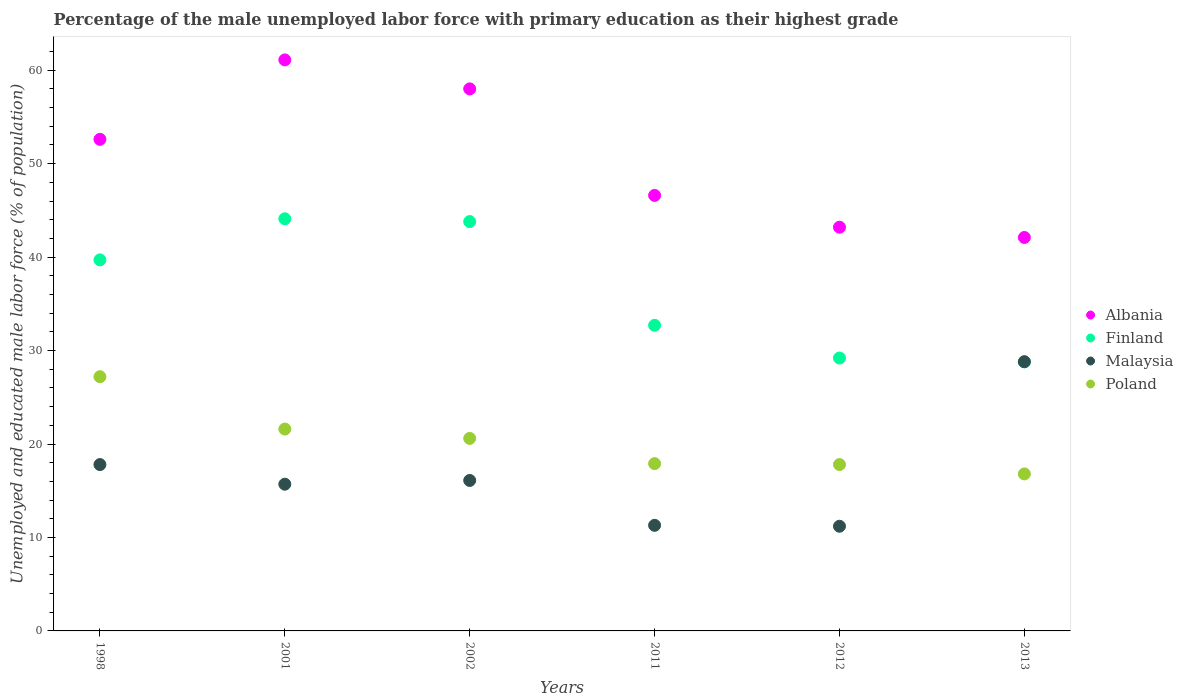How many different coloured dotlines are there?
Keep it short and to the point. 4. What is the percentage of the unemployed male labor force with primary education in Malaysia in 2011?
Provide a short and direct response. 11.3. Across all years, what is the maximum percentage of the unemployed male labor force with primary education in Malaysia?
Ensure brevity in your answer.  28.8. Across all years, what is the minimum percentage of the unemployed male labor force with primary education in Malaysia?
Your answer should be compact. 11.2. In which year was the percentage of the unemployed male labor force with primary education in Poland maximum?
Ensure brevity in your answer.  1998. What is the total percentage of the unemployed male labor force with primary education in Poland in the graph?
Offer a very short reply. 121.9. What is the difference between the percentage of the unemployed male labor force with primary education in Malaysia in 2001 and that in 2013?
Your answer should be very brief. -13.1. What is the difference between the percentage of the unemployed male labor force with primary education in Albania in 2001 and the percentage of the unemployed male labor force with primary education in Finland in 2012?
Your response must be concise. 31.9. What is the average percentage of the unemployed male labor force with primary education in Finland per year?
Ensure brevity in your answer.  36.38. In the year 1998, what is the difference between the percentage of the unemployed male labor force with primary education in Malaysia and percentage of the unemployed male labor force with primary education in Finland?
Offer a very short reply. -21.9. In how many years, is the percentage of the unemployed male labor force with primary education in Albania greater than 28 %?
Your response must be concise. 6. What is the ratio of the percentage of the unemployed male labor force with primary education in Poland in 2012 to that in 2013?
Offer a very short reply. 1.06. Is the percentage of the unemployed male labor force with primary education in Malaysia in 1998 less than that in 2011?
Provide a succinct answer. No. What is the difference between the highest and the second highest percentage of the unemployed male labor force with primary education in Malaysia?
Offer a terse response. 11. What is the difference between the highest and the lowest percentage of the unemployed male labor force with primary education in Malaysia?
Offer a terse response. 17.6. In how many years, is the percentage of the unemployed male labor force with primary education in Albania greater than the average percentage of the unemployed male labor force with primary education in Albania taken over all years?
Make the answer very short. 3. Is it the case that in every year, the sum of the percentage of the unemployed male labor force with primary education in Malaysia and percentage of the unemployed male labor force with primary education in Finland  is greater than the percentage of the unemployed male labor force with primary education in Poland?
Provide a short and direct response. Yes. Does the percentage of the unemployed male labor force with primary education in Albania monotonically increase over the years?
Keep it short and to the point. No. Is the percentage of the unemployed male labor force with primary education in Poland strictly greater than the percentage of the unemployed male labor force with primary education in Albania over the years?
Provide a short and direct response. No. How many dotlines are there?
Keep it short and to the point. 4. What is the difference between two consecutive major ticks on the Y-axis?
Your answer should be very brief. 10. Are the values on the major ticks of Y-axis written in scientific E-notation?
Give a very brief answer. No. Does the graph contain grids?
Keep it short and to the point. No. Where does the legend appear in the graph?
Give a very brief answer. Center right. How many legend labels are there?
Your answer should be compact. 4. How are the legend labels stacked?
Your answer should be compact. Vertical. What is the title of the graph?
Your response must be concise. Percentage of the male unemployed labor force with primary education as their highest grade. Does "Ukraine" appear as one of the legend labels in the graph?
Offer a very short reply. No. What is the label or title of the X-axis?
Your answer should be compact. Years. What is the label or title of the Y-axis?
Keep it short and to the point. Unemployed and educated male labor force (% of population). What is the Unemployed and educated male labor force (% of population) in Albania in 1998?
Provide a succinct answer. 52.6. What is the Unemployed and educated male labor force (% of population) of Finland in 1998?
Provide a short and direct response. 39.7. What is the Unemployed and educated male labor force (% of population) of Malaysia in 1998?
Provide a succinct answer. 17.8. What is the Unemployed and educated male labor force (% of population) of Poland in 1998?
Make the answer very short. 27.2. What is the Unemployed and educated male labor force (% of population) in Albania in 2001?
Your answer should be very brief. 61.1. What is the Unemployed and educated male labor force (% of population) of Finland in 2001?
Make the answer very short. 44.1. What is the Unemployed and educated male labor force (% of population) of Malaysia in 2001?
Keep it short and to the point. 15.7. What is the Unemployed and educated male labor force (% of population) in Poland in 2001?
Provide a short and direct response. 21.6. What is the Unemployed and educated male labor force (% of population) of Albania in 2002?
Your response must be concise. 58. What is the Unemployed and educated male labor force (% of population) in Finland in 2002?
Ensure brevity in your answer.  43.8. What is the Unemployed and educated male labor force (% of population) in Malaysia in 2002?
Offer a terse response. 16.1. What is the Unemployed and educated male labor force (% of population) of Poland in 2002?
Give a very brief answer. 20.6. What is the Unemployed and educated male labor force (% of population) of Albania in 2011?
Ensure brevity in your answer.  46.6. What is the Unemployed and educated male labor force (% of population) in Finland in 2011?
Make the answer very short. 32.7. What is the Unemployed and educated male labor force (% of population) in Malaysia in 2011?
Offer a very short reply. 11.3. What is the Unemployed and educated male labor force (% of population) in Poland in 2011?
Provide a succinct answer. 17.9. What is the Unemployed and educated male labor force (% of population) in Albania in 2012?
Your answer should be very brief. 43.2. What is the Unemployed and educated male labor force (% of population) in Finland in 2012?
Keep it short and to the point. 29.2. What is the Unemployed and educated male labor force (% of population) of Malaysia in 2012?
Make the answer very short. 11.2. What is the Unemployed and educated male labor force (% of population) in Poland in 2012?
Provide a short and direct response. 17.8. What is the Unemployed and educated male labor force (% of population) in Albania in 2013?
Your response must be concise. 42.1. What is the Unemployed and educated male labor force (% of population) in Finland in 2013?
Your answer should be compact. 28.8. What is the Unemployed and educated male labor force (% of population) of Malaysia in 2013?
Keep it short and to the point. 28.8. What is the Unemployed and educated male labor force (% of population) of Poland in 2013?
Offer a terse response. 16.8. Across all years, what is the maximum Unemployed and educated male labor force (% of population) in Albania?
Your answer should be compact. 61.1. Across all years, what is the maximum Unemployed and educated male labor force (% of population) of Finland?
Provide a short and direct response. 44.1. Across all years, what is the maximum Unemployed and educated male labor force (% of population) of Malaysia?
Make the answer very short. 28.8. Across all years, what is the maximum Unemployed and educated male labor force (% of population) of Poland?
Offer a very short reply. 27.2. Across all years, what is the minimum Unemployed and educated male labor force (% of population) in Albania?
Your answer should be compact. 42.1. Across all years, what is the minimum Unemployed and educated male labor force (% of population) in Finland?
Offer a very short reply. 28.8. Across all years, what is the minimum Unemployed and educated male labor force (% of population) in Malaysia?
Provide a succinct answer. 11.2. Across all years, what is the minimum Unemployed and educated male labor force (% of population) in Poland?
Offer a terse response. 16.8. What is the total Unemployed and educated male labor force (% of population) in Albania in the graph?
Your answer should be very brief. 303.6. What is the total Unemployed and educated male labor force (% of population) of Finland in the graph?
Offer a very short reply. 218.3. What is the total Unemployed and educated male labor force (% of population) in Malaysia in the graph?
Give a very brief answer. 100.9. What is the total Unemployed and educated male labor force (% of population) in Poland in the graph?
Offer a terse response. 121.9. What is the difference between the Unemployed and educated male labor force (% of population) in Albania in 1998 and that in 2001?
Ensure brevity in your answer.  -8.5. What is the difference between the Unemployed and educated male labor force (% of population) in Poland in 1998 and that in 2001?
Provide a short and direct response. 5.6. What is the difference between the Unemployed and educated male labor force (% of population) in Malaysia in 1998 and that in 2011?
Your answer should be very brief. 6.5. What is the difference between the Unemployed and educated male labor force (% of population) in Poland in 1998 and that in 2011?
Make the answer very short. 9.3. What is the difference between the Unemployed and educated male labor force (% of population) of Albania in 1998 and that in 2012?
Keep it short and to the point. 9.4. What is the difference between the Unemployed and educated male labor force (% of population) in Finland in 1998 and that in 2012?
Your response must be concise. 10.5. What is the difference between the Unemployed and educated male labor force (% of population) of Malaysia in 1998 and that in 2012?
Your answer should be compact. 6.6. What is the difference between the Unemployed and educated male labor force (% of population) of Albania in 1998 and that in 2013?
Provide a short and direct response. 10.5. What is the difference between the Unemployed and educated male labor force (% of population) in Poland in 1998 and that in 2013?
Ensure brevity in your answer.  10.4. What is the difference between the Unemployed and educated male labor force (% of population) in Finland in 2001 and that in 2002?
Offer a very short reply. 0.3. What is the difference between the Unemployed and educated male labor force (% of population) of Malaysia in 2001 and that in 2002?
Your answer should be very brief. -0.4. What is the difference between the Unemployed and educated male labor force (% of population) in Poland in 2001 and that in 2002?
Keep it short and to the point. 1. What is the difference between the Unemployed and educated male labor force (% of population) in Albania in 2001 and that in 2011?
Provide a short and direct response. 14.5. What is the difference between the Unemployed and educated male labor force (% of population) in Malaysia in 2001 and that in 2011?
Your answer should be compact. 4.4. What is the difference between the Unemployed and educated male labor force (% of population) in Albania in 2001 and that in 2012?
Provide a short and direct response. 17.9. What is the difference between the Unemployed and educated male labor force (% of population) in Malaysia in 2001 and that in 2012?
Keep it short and to the point. 4.5. What is the difference between the Unemployed and educated male labor force (% of population) of Poland in 2001 and that in 2013?
Make the answer very short. 4.8. What is the difference between the Unemployed and educated male labor force (% of population) of Finland in 2002 and that in 2011?
Give a very brief answer. 11.1. What is the difference between the Unemployed and educated male labor force (% of population) in Malaysia in 2002 and that in 2011?
Your answer should be very brief. 4.8. What is the difference between the Unemployed and educated male labor force (% of population) of Poland in 2002 and that in 2011?
Offer a terse response. 2.7. What is the difference between the Unemployed and educated male labor force (% of population) in Albania in 2002 and that in 2012?
Provide a short and direct response. 14.8. What is the difference between the Unemployed and educated male labor force (% of population) of Malaysia in 2002 and that in 2013?
Keep it short and to the point. -12.7. What is the difference between the Unemployed and educated male labor force (% of population) of Albania in 2011 and that in 2012?
Offer a terse response. 3.4. What is the difference between the Unemployed and educated male labor force (% of population) in Malaysia in 2011 and that in 2012?
Offer a very short reply. 0.1. What is the difference between the Unemployed and educated male labor force (% of population) of Poland in 2011 and that in 2012?
Keep it short and to the point. 0.1. What is the difference between the Unemployed and educated male labor force (% of population) in Albania in 2011 and that in 2013?
Give a very brief answer. 4.5. What is the difference between the Unemployed and educated male labor force (% of population) of Malaysia in 2011 and that in 2013?
Provide a succinct answer. -17.5. What is the difference between the Unemployed and educated male labor force (% of population) of Poland in 2011 and that in 2013?
Provide a succinct answer. 1.1. What is the difference between the Unemployed and educated male labor force (% of population) of Albania in 2012 and that in 2013?
Offer a very short reply. 1.1. What is the difference between the Unemployed and educated male labor force (% of population) of Malaysia in 2012 and that in 2013?
Offer a very short reply. -17.6. What is the difference between the Unemployed and educated male labor force (% of population) of Poland in 2012 and that in 2013?
Your answer should be compact. 1. What is the difference between the Unemployed and educated male labor force (% of population) of Albania in 1998 and the Unemployed and educated male labor force (% of population) of Malaysia in 2001?
Offer a very short reply. 36.9. What is the difference between the Unemployed and educated male labor force (% of population) of Albania in 1998 and the Unemployed and educated male labor force (% of population) of Poland in 2001?
Ensure brevity in your answer.  31. What is the difference between the Unemployed and educated male labor force (% of population) in Finland in 1998 and the Unemployed and educated male labor force (% of population) in Malaysia in 2001?
Your answer should be compact. 24. What is the difference between the Unemployed and educated male labor force (% of population) of Finland in 1998 and the Unemployed and educated male labor force (% of population) of Poland in 2001?
Keep it short and to the point. 18.1. What is the difference between the Unemployed and educated male labor force (% of population) in Albania in 1998 and the Unemployed and educated male labor force (% of population) in Finland in 2002?
Ensure brevity in your answer.  8.8. What is the difference between the Unemployed and educated male labor force (% of population) in Albania in 1998 and the Unemployed and educated male labor force (% of population) in Malaysia in 2002?
Give a very brief answer. 36.5. What is the difference between the Unemployed and educated male labor force (% of population) of Albania in 1998 and the Unemployed and educated male labor force (% of population) of Poland in 2002?
Ensure brevity in your answer.  32. What is the difference between the Unemployed and educated male labor force (% of population) in Finland in 1998 and the Unemployed and educated male labor force (% of population) in Malaysia in 2002?
Your answer should be compact. 23.6. What is the difference between the Unemployed and educated male labor force (% of population) of Malaysia in 1998 and the Unemployed and educated male labor force (% of population) of Poland in 2002?
Your answer should be very brief. -2.8. What is the difference between the Unemployed and educated male labor force (% of population) in Albania in 1998 and the Unemployed and educated male labor force (% of population) in Malaysia in 2011?
Provide a succinct answer. 41.3. What is the difference between the Unemployed and educated male labor force (% of population) in Albania in 1998 and the Unemployed and educated male labor force (% of population) in Poland in 2011?
Make the answer very short. 34.7. What is the difference between the Unemployed and educated male labor force (% of population) of Finland in 1998 and the Unemployed and educated male labor force (% of population) of Malaysia in 2011?
Your response must be concise. 28.4. What is the difference between the Unemployed and educated male labor force (% of population) in Finland in 1998 and the Unemployed and educated male labor force (% of population) in Poland in 2011?
Ensure brevity in your answer.  21.8. What is the difference between the Unemployed and educated male labor force (% of population) of Albania in 1998 and the Unemployed and educated male labor force (% of population) of Finland in 2012?
Make the answer very short. 23.4. What is the difference between the Unemployed and educated male labor force (% of population) in Albania in 1998 and the Unemployed and educated male labor force (% of population) in Malaysia in 2012?
Keep it short and to the point. 41.4. What is the difference between the Unemployed and educated male labor force (% of population) of Albania in 1998 and the Unemployed and educated male labor force (% of population) of Poland in 2012?
Your answer should be compact. 34.8. What is the difference between the Unemployed and educated male labor force (% of population) of Finland in 1998 and the Unemployed and educated male labor force (% of population) of Malaysia in 2012?
Keep it short and to the point. 28.5. What is the difference between the Unemployed and educated male labor force (% of population) in Finland in 1998 and the Unemployed and educated male labor force (% of population) in Poland in 2012?
Offer a very short reply. 21.9. What is the difference between the Unemployed and educated male labor force (% of population) in Albania in 1998 and the Unemployed and educated male labor force (% of population) in Finland in 2013?
Offer a very short reply. 23.8. What is the difference between the Unemployed and educated male labor force (% of population) of Albania in 1998 and the Unemployed and educated male labor force (% of population) of Malaysia in 2013?
Offer a terse response. 23.8. What is the difference between the Unemployed and educated male labor force (% of population) in Albania in 1998 and the Unemployed and educated male labor force (% of population) in Poland in 2013?
Make the answer very short. 35.8. What is the difference between the Unemployed and educated male labor force (% of population) of Finland in 1998 and the Unemployed and educated male labor force (% of population) of Malaysia in 2013?
Your answer should be compact. 10.9. What is the difference between the Unemployed and educated male labor force (% of population) of Finland in 1998 and the Unemployed and educated male labor force (% of population) of Poland in 2013?
Offer a very short reply. 22.9. What is the difference between the Unemployed and educated male labor force (% of population) of Malaysia in 1998 and the Unemployed and educated male labor force (% of population) of Poland in 2013?
Offer a terse response. 1. What is the difference between the Unemployed and educated male labor force (% of population) in Albania in 2001 and the Unemployed and educated male labor force (% of population) in Poland in 2002?
Offer a terse response. 40.5. What is the difference between the Unemployed and educated male labor force (% of population) of Albania in 2001 and the Unemployed and educated male labor force (% of population) of Finland in 2011?
Your answer should be compact. 28.4. What is the difference between the Unemployed and educated male labor force (% of population) in Albania in 2001 and the Unemployed and educated male labor force (% of population) in Malaysia in 2011?
Your answer should be compact. 49.8. What is the difference between the Unemployed and educated male labor force (% of population) in Albania in 2001 and the Unemployed and educated male labor force (% of population) in Poland in 2011?
Make the answer very short. 43.2. What is the difference between the Unemployed and educated male labor force (% of population) in Finland in 2001 and the Unemployed and educated male labor force (% of population) in Malaysia in 2011?
Your answer should be very brief. 32.8. What is the difference between the Unemployed and educated male labor force (% of population) of Finland in 2001 and the Unemployed and educated male labor force (% of population) of Poland in 2011?
Your response must be concise. 26.2. What is the difference between the Unemployed and educated male labor force (% of population) in Malaysia in 2001 and the Unemployed and educated male labor force (% of population) in Poland in 2011?
Your answer should be very brief. -2.2. What is the difference between the Unemployed and educated male labor force (% of population) of Albania in 2001 and the Unemployed and educated male labor force (% of population) of Finland in 2012?
Offer a terse response. 31.9. What is the difference between the Unemployed and educated male labor force (% of population) of Albania in 2001 and the Unemployed and educated male labor force (% of population) of Malaysia in 2012?
Your answer should be compact. 49.9. What is the difference between the Unemployed and educated male labor force (% of population) of Albania in 2001 and the Unemployed and educated male labor force (% of population) of Poland in 2012?
Give a very brief answer. 43.3. What is the difference between the Unemployed and educated male labor force (% of population) of Finland in 2001 and the Unemployed and educated male labor force (% of population) of Malaysia in 2012?
Provide a short and direct response. 32.9. What is the difference between the Unemployed and educated male labor force (% of population) in Finland in 2001 and the Unemployed and educated male labor force (% of population) in Poland in 2012?
Your response must be concise. 26.3. What is the difference between the Unemployed and educated male labor force (% of population) of Malaysia in 2001 and the Unemployed and educated male labor force (% of population) of Poland in 2012?
Provide a short and direct response. -2.1. What is the difference between the Unemployed and educated male labor force (% of population) in Albania in 2001 and the Unemployed and educated male labor force (% of population) in Finland in 2013?
Ensure brevity in your answer.  32.3. What is the difference between the Unemployed and educated male labor force (% of population) of Albania in 2001 and the Unemployed and educated male labor force (% of population) of Malaysia in 2013?
Your answer should be very brief. 32.3. What is the difference between the Unemployed and educated male labor force (% of population) in Albania in 2001 and the Unemployed and educated male labor force (% of population) in Poland in 2013?
Your response must be concise. 44.3. What is the difference between the Unemployed and educated male labor force (% of population) in Finland in 2001 and the Unemployed and educated male labor force (% of population) in Poland in 2013?
Your response must be concise. 27.3. What is the difference between the Unemployed and educated male labor force (% of population) in Malaysia in 2001 and the Unemployed and educated male labor force (% of population) in Poland in 2013?
Offer a very short reply. -1.1. What is the difference between the Unemployed and educated male labor force (% of population) of Albania in 2002 and the Unemployed and educated male labor force (% of population) of Finland in 2011?
Provide a succinct answer. 25.3. What is the difference between the Unemployed and educated male labor force (% of population) in Albania in 2002 and the Unemployed and educated male labor force (% of population) in Malaysia in 2011?
Make the answer very short. 46.7. What is the difference between the Unemployed and educated male labor force (% of population) in Albania in 2002 and the Unemployed and educated male labor force (% of population) in Poland in 2011?
Give a very brief answer. 40.1. What is the difference between the Unemployed and educated male labor force (% of population) of Finland in 2002 and the Unemployed and educated male labor force (% of population) of Malaysia in 2011?
Make the answer very short. 32.5. What is the difference between the Unemployed and educated male labor force (% of population) of Finland in 2002 and the Unemployed and educated male labor force (% of population) of Poland in 2011?
Offer a very short reply. 25.9. What is the difference between the Unemployed and educated male labor force (% of population) of Albania in 2002 and the Unemployed and educated male labor force (% of population) of Finland in 2012?
Provide a short and direct response. 28.8. What is the difference between the Unemployed and educated male labor force (% of population) of Albania in 2002 and the Unemployed and educated male labor force (% of population) of Malaysia in 2012?
Your answer should be compact. 46.8. What is the difference between the Unemployed and educated male labor force (% of population) in Albania in 2002 and the Unemployed and educated male labor force (% of population) in Poland in 2012?
Offer a very short reply. 40.2. What is the difference between the Unemployed and educated male labor force (% of population) of Finland in 2002 and the Unemployed and educated male labor force (% of population) of Malaysia in 2012?
Keep it short and to the point. 32.6. What is the difference between the Unemployed and educated male labor force (% of population) of Albania in 2002 and the Unemployed and educated male labor force (% of population) of Finland in 2013?
Ensure brevity in your answer.  29.2. What is the difference between the Unemployed and educated male labor force (% of population) in Albania in 2002 and the Unemployed and educated male labor force (% of population) in Malaysia in 2013?
Make the answer very short. 29.2. What is the difference between the Unemployed and educated male labor force (% of population) in Albania in 2002 and the Unemployed and educated male labor force (% of population) in Poland in 2013?
Ensure brevity in your answer.  41.2. What is the difference between the Unemployed and educated male labor force (% of population) in Finland in 2002 and the Unemployed and educated male labor force (% of population) in Poland in 2013?
Offer a terse response. 27. What is the difference between the Unemployed and educated male labor force (% of population) of Malaysia in 2002 and the Unemployed and educated male labor force (% of population) of Poland in 2013?
Offer a very short reply. -0.7. What is the difference between the Unemployed and educated male labor force (% of population) of Albania in 2011 and the Unemployed and educated male labor force (% of population) of Malaysia in 2012?
Your answer should be compact. 35.4. What is the difference between the Unemployed and educated male labor force (% of population) in Albania in 2011 and the Unemployed and educated male labor force (% of population) in Poland in 2012?
Your answer should be very brief. 28.8. What is the difference between the Unemployed and educated male labor force (% of population) in Malaysia in 2011 and the Unemployed and educated male labor force (% of population) in Poland in 2012?
Your answer should be very brief. -6.5. What is the difference between the Unemployed and educated male labor force (% of population) of Albania in 2011 and the Unemployed and educated male labor force (% of population) of Poland in 2013?
Your response must be concise. 29.8. What is the difference between the Unemployed and educated male labor force (% of population) of Finland in 2011 and the Unemployed and educated male labor force (% of population) of Poland in 2013?
Ensure brevity in your answer.  15.9. What is the difference between the Unemployed and educated male labor force (% of population) of Albania in 2012 and the Unemployed and educated male labor force (% of population) of Poland in 2013?
Give a very brief answer. 26.4. What is the difference between the Unemployed and educated male labor force (% of population) in Finland in 2012 and the Unemployed and educated male labor force (% of population) in Poland in 2013?
Make the answer very short. 12.4. What is the difference between the Unemployed and educated male labor force (% of population) of Malaysia in 2012 and the Unemployed and educated male labor force (% of population) of Poland in 2013?
Your answer should be very brief. -5.6. What is the average Unemployed and educated male labor force (% of population) of Albania per year?
Ensure brevity in your answer.  50.6. What is the average Unemployed and educated male labor force (% of population) in Finland per year?
Your answer should be very brief. 36.38. What is the average Unemployed and educated male labor force (% of population) of Malaysia per year?
Your response must be concise. 16.82. What is the average Unemployed and educated male labor force (% of population) in Poland per year?
Ensure brevity in your answer.  20.32. In the year 1998, what is the difference between the Unemployed and educated male labor force (% of population) of Albania and Unemployed and educated male labor force (% of population) of Finland?
Your answer should be very brief. 12.9. In the year 1998, what is the difference between the Unemployed and educated male labor force (% of population) of Albania and Unemployed and educated male labor force (% of population) of Malaysia?
Provide a succinct answer. 34.8. In the year 1998, what is the difference between the Unemployed and educated male labor force (% of population) of Albania and Unemployed and educated male labor force (% of population) of Poland?
Provide a succinct answer. 25.4. In the year 1998, what is the difference between the Unemployed and educated male labor force (% of population) of Finland and Unemployed and educated male labor force (% of population) of Malaysia?
Provide a short and direct response. 21.9. In the year 1998, what is the difference between the Unemployed and educated male labor force (% of population) in Malaysia and Unemployed and educated male labor force (% of population) in Poland?
Your answer should be very brief. -9.4. In the year 2001, what is the difference between the Unemployed and educated male labor force (% of population) of Albania and Unemployed and educated male labor force (% of population) of Malaysia?
Your response must be concise. 45.4. In the year 2001, what is the difference between the Unemployed and educated male labor force (% of population) of Albania and Unemployed and educated male labor force (% of population) of Poland?
Offer a very short reply. 39.5. In the year 2001, what is the difference between the Unemployed and educated male labor force (% of population) of Finland and Unemployed and educated male labor force (% of population) of Malaysia?
Your answer should be compact. 28.4. In the year 2001, what is the difference between the Unemployed and educated male labor force (% of population) of Finland and Unemployed and educated male labor force (% of population) of Poland?
Give a very brief answer. 22.5. In the year 2001, what is the difference between the Unemployed and educated male labor force (% of population) of Malaysia and Unemployed and educated male labor force (% of population) of Poland?
Your answer should be compact. -5.9. In the year 2002, what is the difference between the Unemployed and educated male labor force (% of population) of Albania and Unemployed and educated male labor force (% of population) of Malaysia?
Provide a succinct answer. 41.9. In the year 2002, what is the difference between the Unemployed and educated male labor force (% of population) of Albania and Unemployed and educated male labor force (% of population) of Poland?
Give a very brief answer. 37.4. In the year 2002, what is the difference between the Unemployed and educated male labor force (% of population) in Finland and Unemployed and educated male labor force (% of population) in Malaysia?
Make the answer very short. 27.7. In the year 2002, what is the difference between the Unemployed and educated male labor force (% of population) in Finland and Unemployed and educated male labor force (% of population) in Poland?
Provide a succinct answer. 23.2. In the year 2011, what is the difference between the Unemployed and educated male labor force (% of population) of Albania and Unemployed and educated male labor force (% of population) of Finland?
Your response must be concise. 13.9. In the year 2011, what is the difference between the Unemployed and educated male labor force (% of population) of Albania and Unemployed and educated male labor force (% of population) of Malaysia?
Provide a short and direct response. 35.3. In the year 2011, what is the difference between the Unemployed and educated male labor force (% of population) in Albania and Unemployed and educated male labor force (% of population) in Poland?
Your answer should be compact. 28.7. In the year 2011, what is the difference between the Unemployed and educated male labor force (% of population) in Finland and Unemployed and educated male labor force (% of population) in Malaysia?
Make the answer very short. 21.4. In the year 2011, what is the difference between the Unemployed and educated male labor force (% of population) of Finland and Unemployed and educated male labor force (% of population) of Poland?
Your answer should be compact. 14.8. In the year 2011, what is the difference between the Unemployed and educated male labor force (% of population) in Malaysia and Unemployed and educated male labor force (% of population) in Poland?
Your answer should be very brief. -6.6. In the year 2012, what is the difference between the Unemployed and educated male labor force (% of population) of Albania and Unemployed and educated male labor force (% of population) of Finland?
Your response must be concise. 14. In the year 2012, what is the difference between the Unemployed and educated male labor force (% of population) of Albania and Unemployed and educated male labor force (% of population) of Poland?
Your answer should be compact. 25.4. In the year 2012, what is the difference between the Unemployed and educated male labor force (% of population) of Malaysia and Unemployed and educated male labor force (% of population) of Poland?
Your response must be concise. -6.6. In the year 2013, what is the difference between the Unemployed and educated male labor force (% of population) in Albania and Unemployed and educated male labor force (% of population) in Poland?
Keep it short and to the point. 25.3. In the year 2013, what is the difference between the Unemployed and educated male labor force (% of population) in Finland and Unemployed and educated male labor force (% of population) in Poland?
Your answer should be very brief. 12. What is the ratio of the Unemployed and educated male labor force (% of population) of Albania in 1998 to that in 2001?
Keep it short and to the point. 0.86. What is the ratio of the Unemployed and educated male labor force (% of population) of Finland in 1998 to that in 2001?
Offer a very short reply. 0.9. What is the ratio of the Unemployed and educated male labor force (% of population) of Malaysia in 1998 to that in 2001?
Give a very brief answer. 1.13. What is the ratio of the Unemployed and educated male labor force (% of population) of Poland in 1998 to that in 2001?
Ensure brevity in your answer.  1.26. What is the ratio of the Unemployed and educated male labor force (% of population) in Albania in 1998 to that in 2002?
Make the answer very short. 0.91. What is the ratio of the Unemployed and educated male labor force (% of population) in Finland in 1998 to that in 2002?
Offer a very short reply. 0.91. What is the ratio of the Unemployed and educated male labor force (% of population) in Malaysia in 1998 to that in 2002?
Make the answer very short. 1.11. What is the ratio of the Unemployed and educated male labor force (% of population) in Poland in 1998 to that in 2002?
Your response must be concise. 1.32. What is the ratio of the Unemployed and educated male labor force (% of population) of Albania in 1998 to that in 2011?
Your answer should be very brief. 1.13. What is the ratio of the Unemployed and educated male labor force (% of population) in Finland in 1998 to that in 2011?
Offer a very short reply. 1.21. What is the ratio of the Unemployed and educated male labor force (% of population) of Malaysia in 1998 to that in 2011?
Your answer should be very brief. 1.58. What is the ratio of the Unemployed and educated male labor force (% of population) in Poland in 1998 to that in 2011?
Offer a very short reply. 1.52. What is the ratio of the Unemployed and educated male labor force (% of population) of Albania in 1998 to that in 2012?
Ensure brevity in your answer.  1.22. What is the ratio of the Unemployed and educated male labor force (% of population) of Finland in 1998 to that in 2012?
Provide a succinct answer. 1.36. What is the ratio of the Unemployed and educated male labor force (% of population) in Malaysia in 1998 to that in 2012?
Offer a terse response. 1.59. What is the ratio of the Unemployed and educated male labor force (% of population) in Poland in 1998 to that in 2012?
Offer a terse response. 1.53. What is the ratio of the Unemployed and educated male labor force (% of population) of Albania in 1998 to that in 2013?
Your answer should be very brief. 1.25. What is the ratio of the Unemployed and educated male labor force (% of population) of Finland in 1998 to that in 2013?
Provide a succinct answer. 1.38. What is the ratio of the Unemployed and educated male labor force (% of population) of Malaysia in 1998 to that in 2013?
Provide a short and direct response. 0.62. What is the ratio of the Unemployed and educated male labor force (% of population) of Poland in 1998 to that in 2013?
Your answer should be very brief. 1.62. What is the ratio of the Unemployed and educated male labor force (% of population) in Albania in 2001 to that in 2002?
Ensure brevity in your answer.  1.05. What is the ratio of the Unemployed and educated male labor force (% of population) in Finland in 2001 to that in 2002?
Give a very brief answer. 1.01. What is the ratio of the Unemployed and educated male labor force (% of population) in Malaysia in 2001 to that in 2002?
Your answer should be compact. 0.98. What is the ratio of the Unemployed and educated male labor force (% of population) in Poland in 2001 to that in 2002?
Ensure brevity in your answer.  1.05. What is the ratio of the Unemployed and educated male labor force (% of population) of Albania in 2001 to that in 2011?
Your answer should be very brief. 1.31. What is the ratio of the Unemployed and educated male labor force (% of population) in Finland in 2001 to that in 2011?
Make the answer very short. 1.35. What is the ratio of the Unemployed and educated male labor force (% of population) in Malaysia in 2001 to that in 2011?
Your answer should be very brief. 1.39. What is the ratio of the Unemployed and educated male labor force (% of population) of Poland in 2001 to that in 2011?
Your answer should be very brief. 1.21. What is the ratio of the Unemployed and educated male labor force (% of population) in Albania in 2001 to that in 2012?
Your answer should be very brief. 1.41. What is the ratio of the Unemployed and educated male labor force (% of population) of Finland in 2001 to that in 2012?
Your answer should be very brief. 1.51. What is the ratio of the Unemployed and educated male labor force (% of population) of Malaysia in 2001 to that in 2012?
Make the answer very short. 1.4. What is the ratio of the Unemployed and educated male labor force (% of population) in Poland in 2001 to that in 2012?
Provide a short and direct response. 1.21. What is the ratio of the Unemployed and educated male labor force (% of population) of Albania in 2001 to that in 2013?
Give a very brief answer. 1.45. What is the ratio of the Unemployed and educated male labor force (% of population) in Finland in 2001 to that in 2013?
Your answer should be very brief. 1.53. What is the ratio of the Unemployed and educated male labor force (% of population) of Malaysia in 2001 to that in 2013?
Provide a succinct answer. 0.55. What is the ratio of the Unemployed and educated male labor force (% of population) of Poland in 2001 to that in 2013?
Give a very brief answer. 1.29. What is the ratio of the Unemployed and educated male labor force (% of population) of Albania in 2002 to that in 2011?
Your response must be concise. 1.24. What is the ratio of the Unemployed and educated male labor force (% of population) of Finland in 2002 to that in 2011?
Ensure brevity in your answer.  1.34. What is the ratio of the Unemployed and educated male labor force (% of population) of Malaysia in 2002 to that in 2011?
Your response must be concise. 1.42. What is the ratio of the Unemployed and educated male labor force (% of population) in Poland in 2002 to that in 2011?
Ensure brevity in your answer.  1.15. What is the ratio of the Unemployed and educated male labor force (% of population) in Albania in 2002 to that in 2012?
Give a very brief answer. 1.34. What is the ratio of the Unemployed and educated male labor force (% of population) of Malaysia in 2002 to that in 2012?
Offer a terse response. 1.44. What is the ratio of the Unemployed and educated male labor force (% of population) in Poland in 2002 to that in 2012?
Your answer should be compact. 1.16. What is the ratio of the Unemployed and educated male labor force (% of population) in Albania in 2002 to that in 2013?
Give a very brief answer. 1.38. What is the ratio of the Unemployed and educated male labor force (% of population) of Finland in 2002 to that in 2013?
Your answer should be very brief. 1.52. What is the ratio of the Unemployed and educated male labor force (% of population) in Malaysia in 2002 to that in 2013?
Your answer should be very brief. 0.56. What is the ratio of the Unemployed and educated male labor force (% of population) of Poland in 2002 to that in 2013?
Offer a very short reply. 1.23. What is the ratio of the Unemployed and educated male labor force (% of population) in Albania in 2011 to that in 2012?
Keep it short and to the point. 1.08. What is the ratio of the Unemployed and educated male labor force (% of population) in Finland in 2011 to that in 2012?
Your response must be concise. 1.12. What is the ratio of the Unemployed and educated male labor force (% of population) in Malaysia in 2011 to that in 2012?
Offer a very short reply. 1.01. What is the ratio of the Unemployed and educated male labor force (% of population) in Poland in 2011 to that in 2012?
Ensure brevity in your answer.  1.01. What is the ratio of the Unemployed and educated male labor force (% of population) in Albania in 2011 to that in 2013?
Ensure brevity in your answer.  1.11. What is the ratio of the Unemployed and educated male labor force (% of population) of Finland in 2011 to that in 2013?
Give a very brief answer. 1.14. What is the ratio of the Unemployed and educated male labor force (% of population) of Malaysia in 2011 to that in 2013?
Ensure brevity in your answer.  0.39. What is the ratio of the Unemployed and educated male labor force (% of population) in Poland in 2011 to that in 2013?
Provide a short and direct response. 1.07. What is the ratio of the Unemployed and educated male labor force (% of population) of Albania in 2012 to that in 2013?
Your answer should be compact. 1.03. What is the ratio of the Unemployed and educated male labor force (% of population) in Finland in 2012 to that in 2013?
Your answer should be very brief. 1.01. What is the ratio of the Unemployed and educated male labor force (% of population) in Malaysia in 2012 to that in 2013?
Ensure brevity in your answer.  0.39. What is the ratio of the Unemployed and educated male labor force (% of population) in Poland in 2012 to that in 2013?
Ensure brevity in your answer.  1.06. What is the difference between the highest and the second highest Unemployed and educated male labor force (% of population) in Albania?
Give a very brief answer. 3.1. What is the difference between the highest and the second highest Unemployed and educated male labor force (% of population) in Malaysia?
Provide a short and direct response. 11. What is the difference between the highest and the second highest Unemployed and educated male labor force (% of population) in Poland?
Provide a short and direct response. 5.6. What is the difference between the highest and the lowest Unemployed and educated male labor force (% of population) of Finland?
Give a very brief answer. 15.3. What is the difference between the highest and the lowest Unemployed and educated male labor force (% of population) in Poland?
Provide a succinct answer. 10.4. 